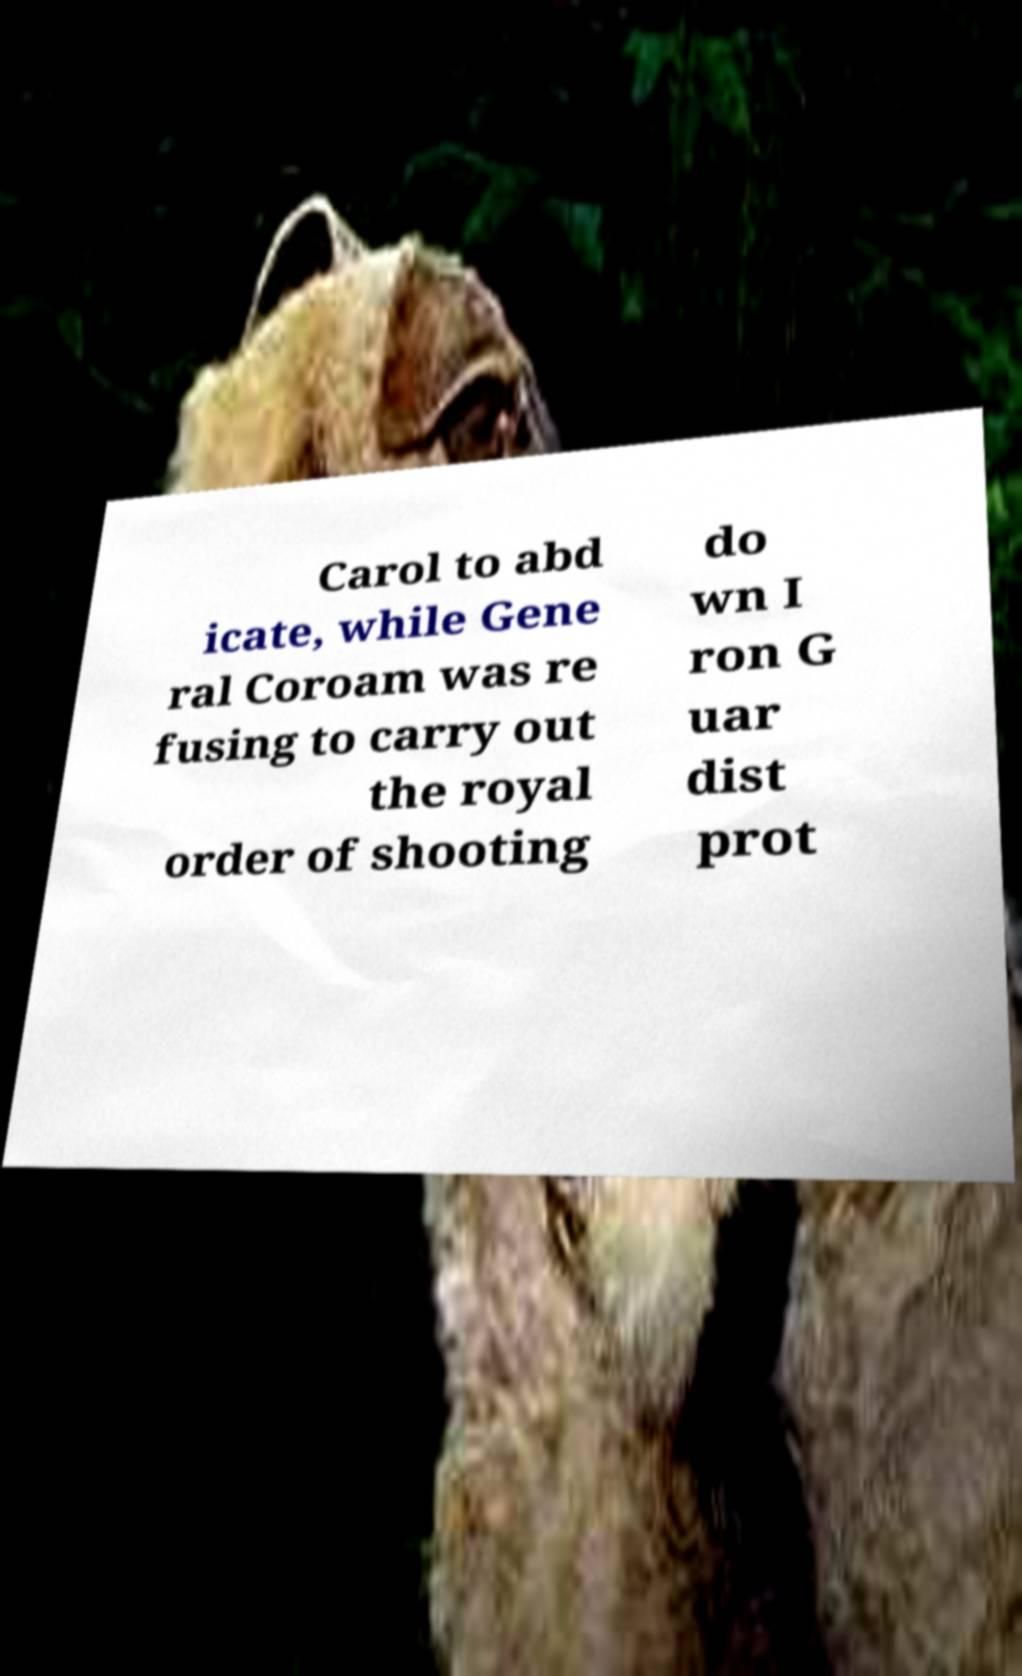Can you read and provide the text displayed in the image?This photo seems to have some interesting text. Can you extract and type it out for me? Carol to abd icate, while Gene ral Coroam was re fusing to carry out the royal order of shooting do wn I ron G uar dist prot 